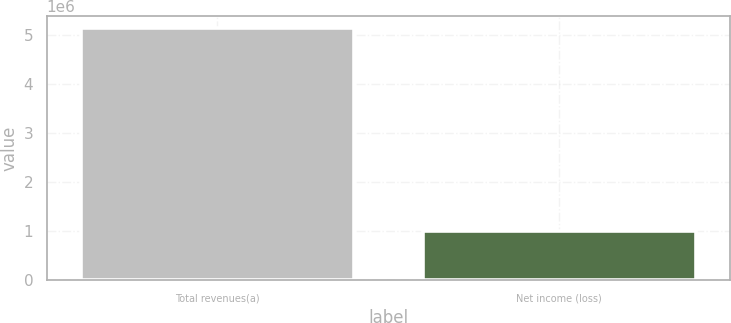<chart> <loc_0><loc_0><loc_500><loc_500><bar_chart><fcel>Total revenues(a)<fcel>Net income (loss)<nl><fcel>5.13266e+06<fcel>1.01146e+06<nl></chart> 